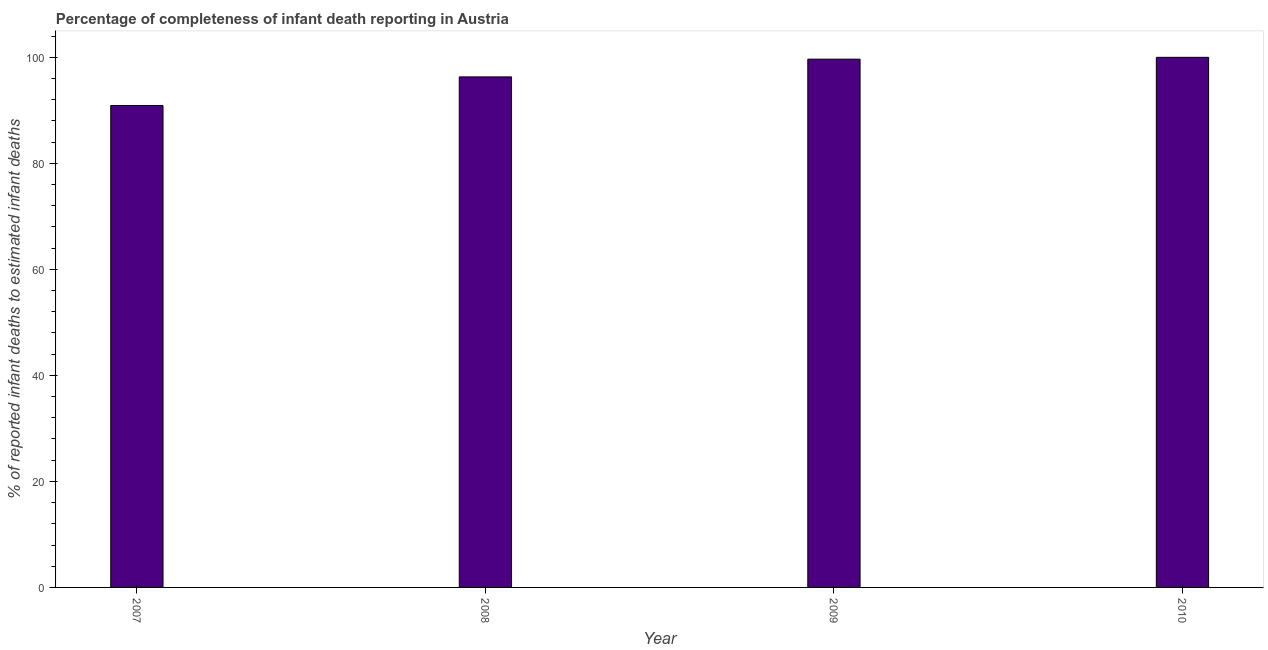Does the graph contain any zero values?
Give a very brief answer. No. What is the title of the graph?
Make the answer very short. Percentage of completeness of infant death reporting in Austria. What is the label or title of the Y-axis?
Your answer should be compact. % of reported infant deaths to estimated infant deaths. What is the completeness of infant death reporting in 2007?
Provide a succinct answer. 90.91. Across all years, what is the maximum completeness of infant death reporting?
Make the answer very short. 100. Across all years, what is the minimum completeness of infant death reporting?
Make the answer very short. 90.91. In which year was the completeness of infant death reporting maximum?
Offer a very short reply. 2010. In which year was the completeness of infant death reporting minimum?
Give a very brief answer. 2007. What is the sum of the completeness of infant death reporting?
Your answer should be very brief. 386.87. What is the difference between the completeness of infant death reporting in 2008 and 2009?
Ensure brevity in your answer.  -3.35. What is the average completeness of infant death reporting per year?
Make the answer very short. 96.72. What is the median completeness of infant death reporting?
Provide a short and direct response. 97.98. In how many years, is the completeness of infant death reporting greater than 96 %?
Provide a short and direct response. 3. Do a majority of the years between 2008 and 2009 (inclusive) have completeness of infant death reporting greater than 92 %?
Your response must be concise. Yes. What is the ratio of the completeness of infant death reporting in 2007 to that in 2009?
Provide a succinct answer. 0.91. Is the completeness of infant death reporting in 2007 less than that in 2008?
Your answer should be compact. Yes. What is the difference between the highest and the second highest completeness of infant death reporting?
Provide a short and direct response. 0.34. Is the sum of the completeness of infant death reporting in 2008 and 2009 greater than the maximum completeness of infant death reporting across all years?
Your answer should be compact. Yes. What is the difference between the highest and the lowest completeness of infant death reporting?
Give a very brief answer. 9.09. In how many years, is the completeness of infant death reporting greater than the average completeness of infant death reporting taken over all years?
Your response must be concise. 2. Are all the bars in the graph horizontal?
Offer a terse response. No. How many years are there in the graph?
Give a very brief answer. 4. What is the % of reported infant deaths to estimated infant deaths of 2007?
Your response must be concise. 90.91. What is the % of reported infant deaths to estimated infant deaths of 2008?
Give a very brief answer. 96.31. What is the % of reported infant deaths to estimated infant deaths in 2009?
Make the answer very short. 99.66. What is the difference between the % of reported infant deaths to estimated infant deaths in 2007 and 2008?
Provide a succinct answer. -5.4. What is the difference between the % of reported infant deaths to estimated infant deaths in 2007 and 2009?
Keep it short and to the point. -8.75. What is the difference between the % of reported infant deaths to estimated infant deaths in 2007 and 2010?
Offer a very short reply. -9.09. What is the difference between the % of reported infant deaths to estimated infant deaths in 2008 and 2009?
Offer a very short reply. -3.35. What is the difference between the % of reported infant deaths to estimated infant deaths in 2008 and 2010?
Keep it short and to the point. -3.69. What is the difference between the % of reported infant deaths to estimated infant deaths in 2009 and 2010?
Your response must be concise. -0.34. What is the ratio of the % of reported infant deaths to estimated infant deaths in 2007 to that in 2008?
Offer a terse response. 0.94. What is the ratio of the % of reported infant deaths to estimated infant deaths in 2007 to that in 2009?
Ensure brevity in your answer.  0.91. What is the ratio of the % of reported infant deaths to estimated infant deaths in 2007 to that in 2010?
Make the answer very short. 0.91. What is the ratio of the % of reported infant deaths to estimated infant deaths in 2008 to that in 2009?
Give a very brief answer. 0.97. What is the ratio of the % of reported infant deaths to estimated infant deaths in 2008 to that in 2010?
Make the answer very short. 0.96. 